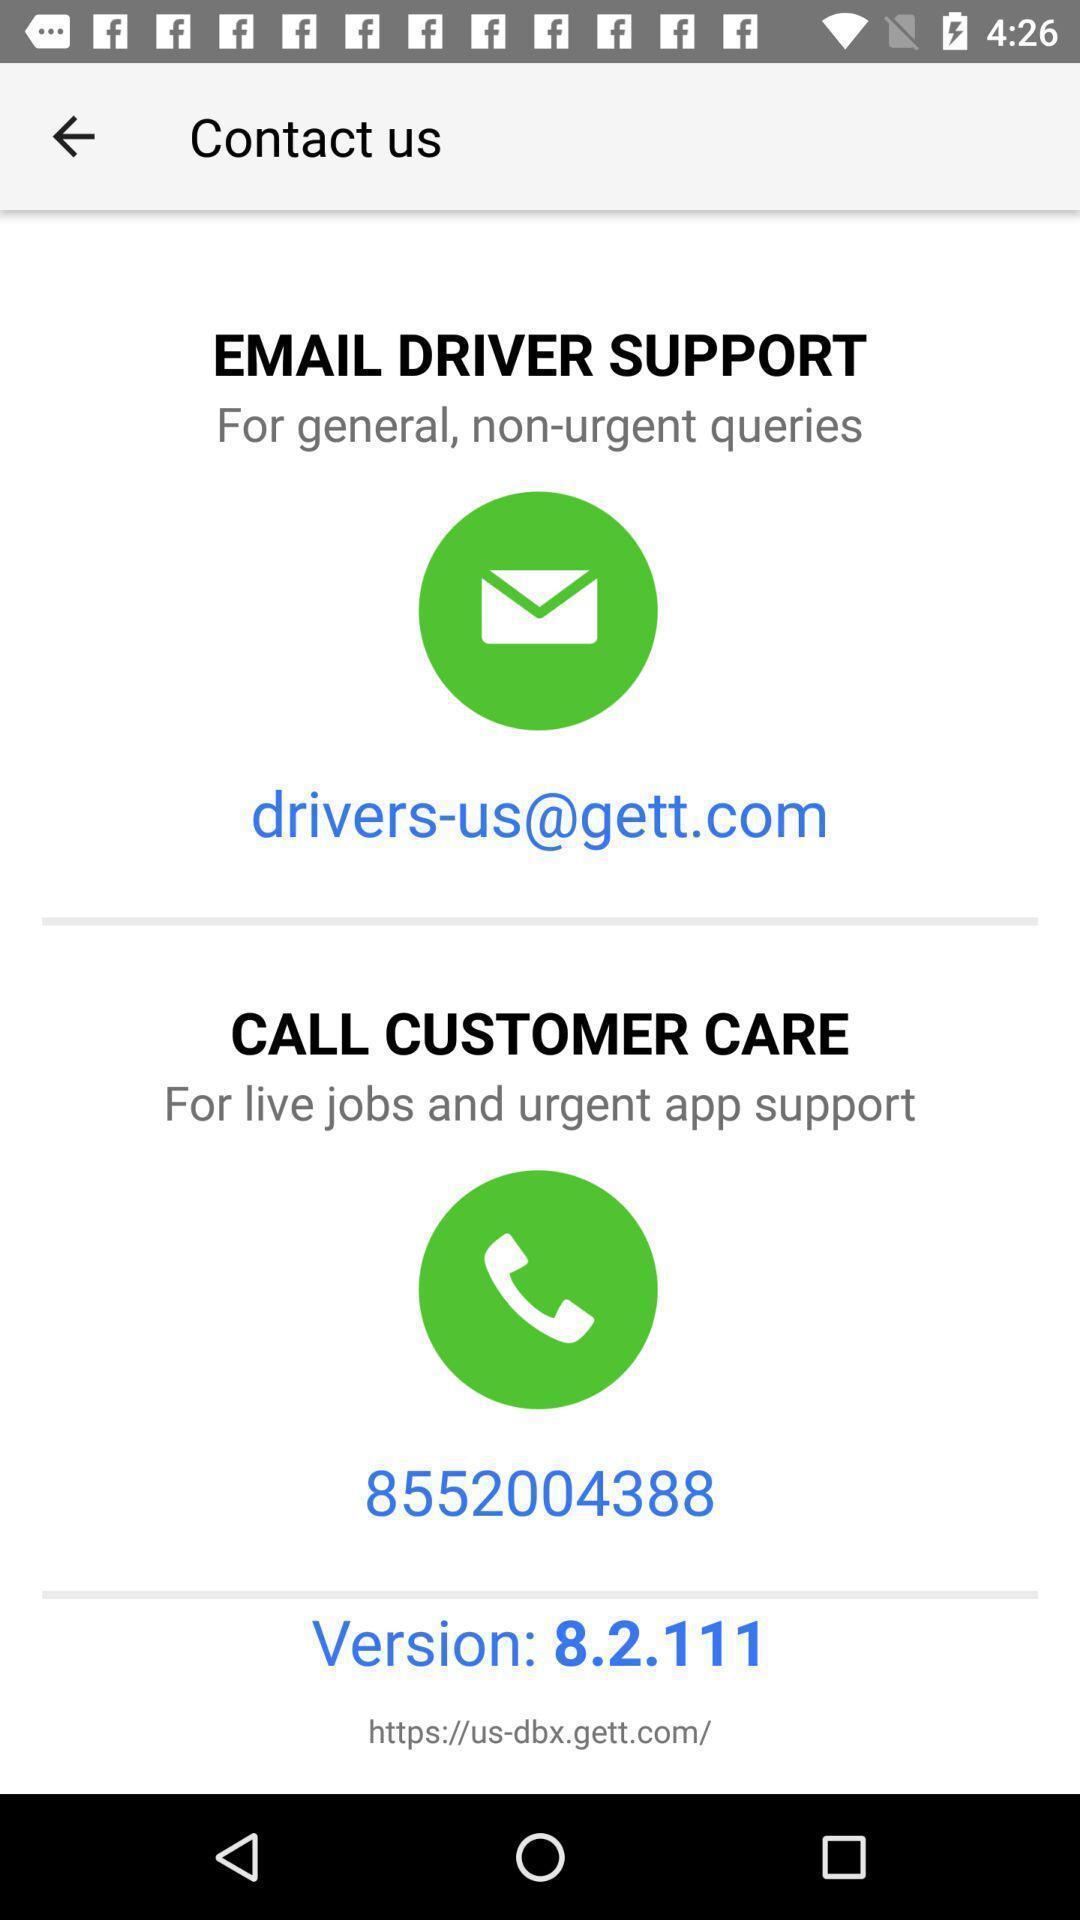What is the overall content of this screenshot? Page showing contact details. 